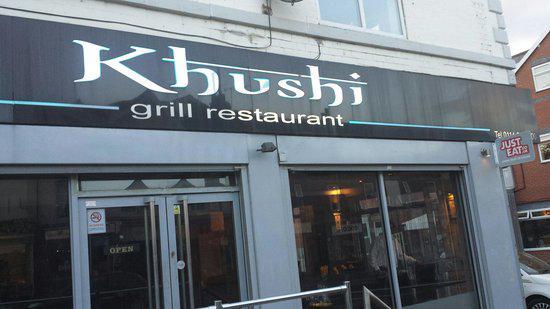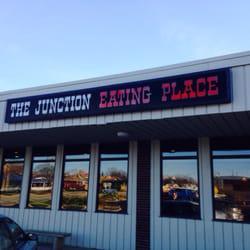The first image is the image on the left, the second image is the image on the right. Given the left and right images, does the statement "The image shows the outside of a restaurant with it's name displayed near the top of the building" hold true? Answer yes or no. Yes. The first image is the image on the left, the second image is the image on the right. Given the left and right images, does the statement "One image shows a flat-topped building with a sign lettered in two colors above a row of six rectangular windows." hold true? Answer yes or no. Yes. 